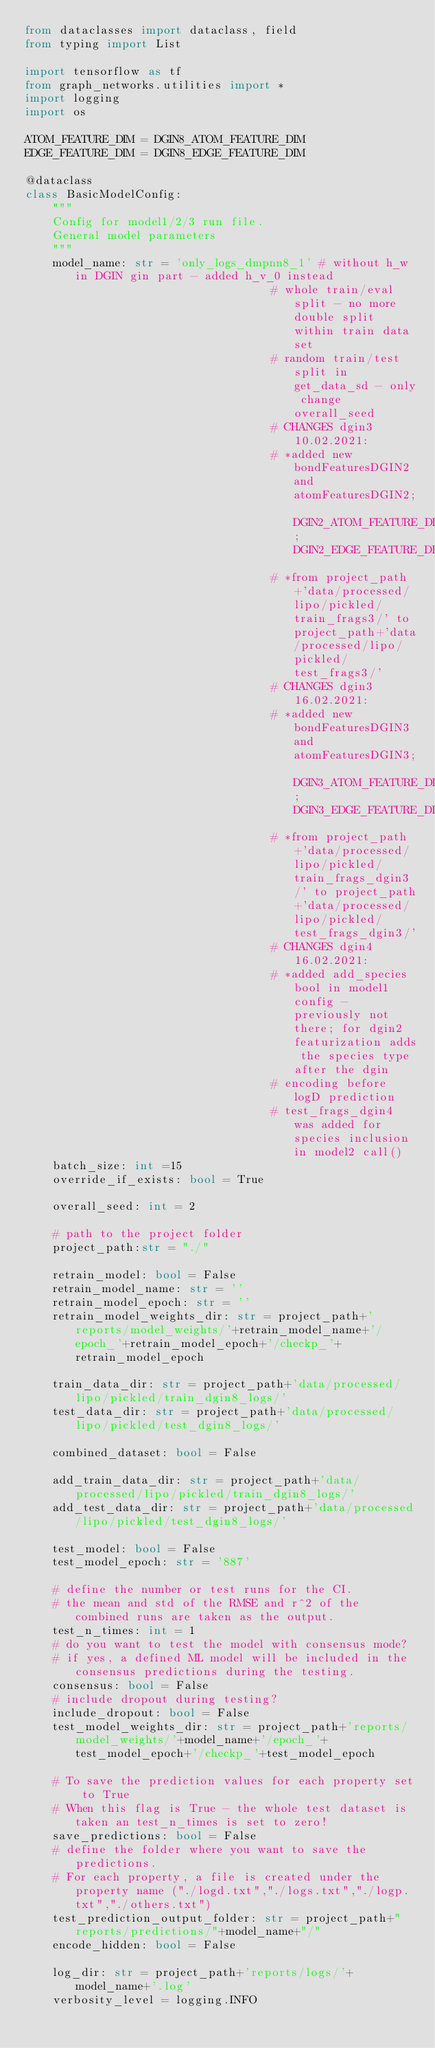<code> <loc_0><loc_0><loc_500><loc_500><_Python_>from dataclasses import dataclass, field
from typing import List

import tensorflow as tf
from graph_networks.utilities import * 
import logging
import os

ATOM_FEATURE_DIM = DGIN8_ATOM_FEATURE_DIM
EDGE_FEATURE_DIM = DGIN8_EDGE_FEATURE_DIM

@dataclass
class BasicModelConfig:
    """
    Config for model1/2/3 run file.
    General model parameters
    """
    model_name: str = 'only_logs_dmpnn8_1' # without h_w in DGIN gin part - added h_v_0 instead
                                    # whole train/eval split - no more double split within train data set
                                    # random train/test split in get_data_sd - only change overall_seed
                                    # CHANGES dgin3 10.02.2021:
                                    # *added new bondFeaturesDGIN2 and atomFeaturesDGIN2; DGIN2_ATOM_FEATURE_DIM; DGIN2_EDGE_FEATURE_DIM
                                    # *from project_path+'data/processed/lipo/pickled/train_frags3/' to project_path+'data/processed/lipo/pickled/test_frags3/'
                                    # CHANGES dgin3 16.02.2021:
                                    # *added new bondFeaturesDGIN3 and atomFeaturesDGIN3; DGIN3_ATOM_FEATURE_DIM; DGIN3_EDGE_FEATURE_DIM
                                    # *from project_path+'data/processed/lipo/pickled/train_frags_dgin3/' to project_path+'data/processed/lipo/pickled/test_frags_dgin3/'
                                    # CHANGES dgin4 16.02.2021:
                                    # *added add_species bool in model1 config - previously not there; for dgin2 featurization adds the species type after the dgin 
                                    # encoding before logD prediction
                                    # test_frags_dgin4 was added for species inclusion in model2 call()
    batch_size: int =15
    override_if_exists: bool = True

    overall_seed: int = 2
    
    # path to the project folder 
    project_path:str = "./" 

    retrain_model: bool = False
    retrain_model_name: str = ''
    retrain_model_epoch: str = ''
    retrain_model_weights_dir: str = project_path+'reports/model_weights/'+retrain_model_name+'/epoch_'+retrain_model_epoch+'/checkp_'+retrain_model_epoch

    train_data_dir: str = project_path+'data/processed/lipo/pickled/train_dgin8_logs/'
    test_data_dir: str = project_path+'data/processed/lipo/pickled/test_dgin8_logs/'

    combined_dataset: bool = False

    add_train_data_dir: str = project_path+'data/processed/lipo/pickled/train_dgin8_logs/'
    add_test_data_dir: str = project_path+'data/processed/lipo/pickled/test_dgin8_logs/'

    test_model: bool = False
    test_model_epoch: str = '887'

    # define the number or test runs for the CI. 
    # the mean and std of the RMSE and r^2 of the combined runs are taken as the output. 
    test_n_times: int = 1 
    # do you want to test the model with consensus mode? 
    # if yes, a defined ML model will be included in the consensus predictions during the testing. 
    consensus: bool = False 
    # include dropout during testing?
    include_dropout: bool = False
    test_model_weights_dir: str = project_path+'reports/model_weights/'+model_name+'/epoch_'+test_model_epoch+'/checkp_'+test_model_epoch

    # To save the prediction values for each property set to True 
    # When this flag is True - the whole test dataset is taken an test_n_times is set to zero! 
    save_predictions: bool = False 
    # define the folder where you want to save the predictions. 
    # For each property, a file is created under the property name ("./logd.txt","./logs.txt","./logp.txt","./others.txt") 
    test_prediction_output_folder: str = project_path+"reports/predictions/"+model_name+"/" 
    encode_hidden: bool = False

    log_dir: str = project_path+'reports/logs/'+model_name+'.log' 
    verbosity_level = logging.INFO
</code> 